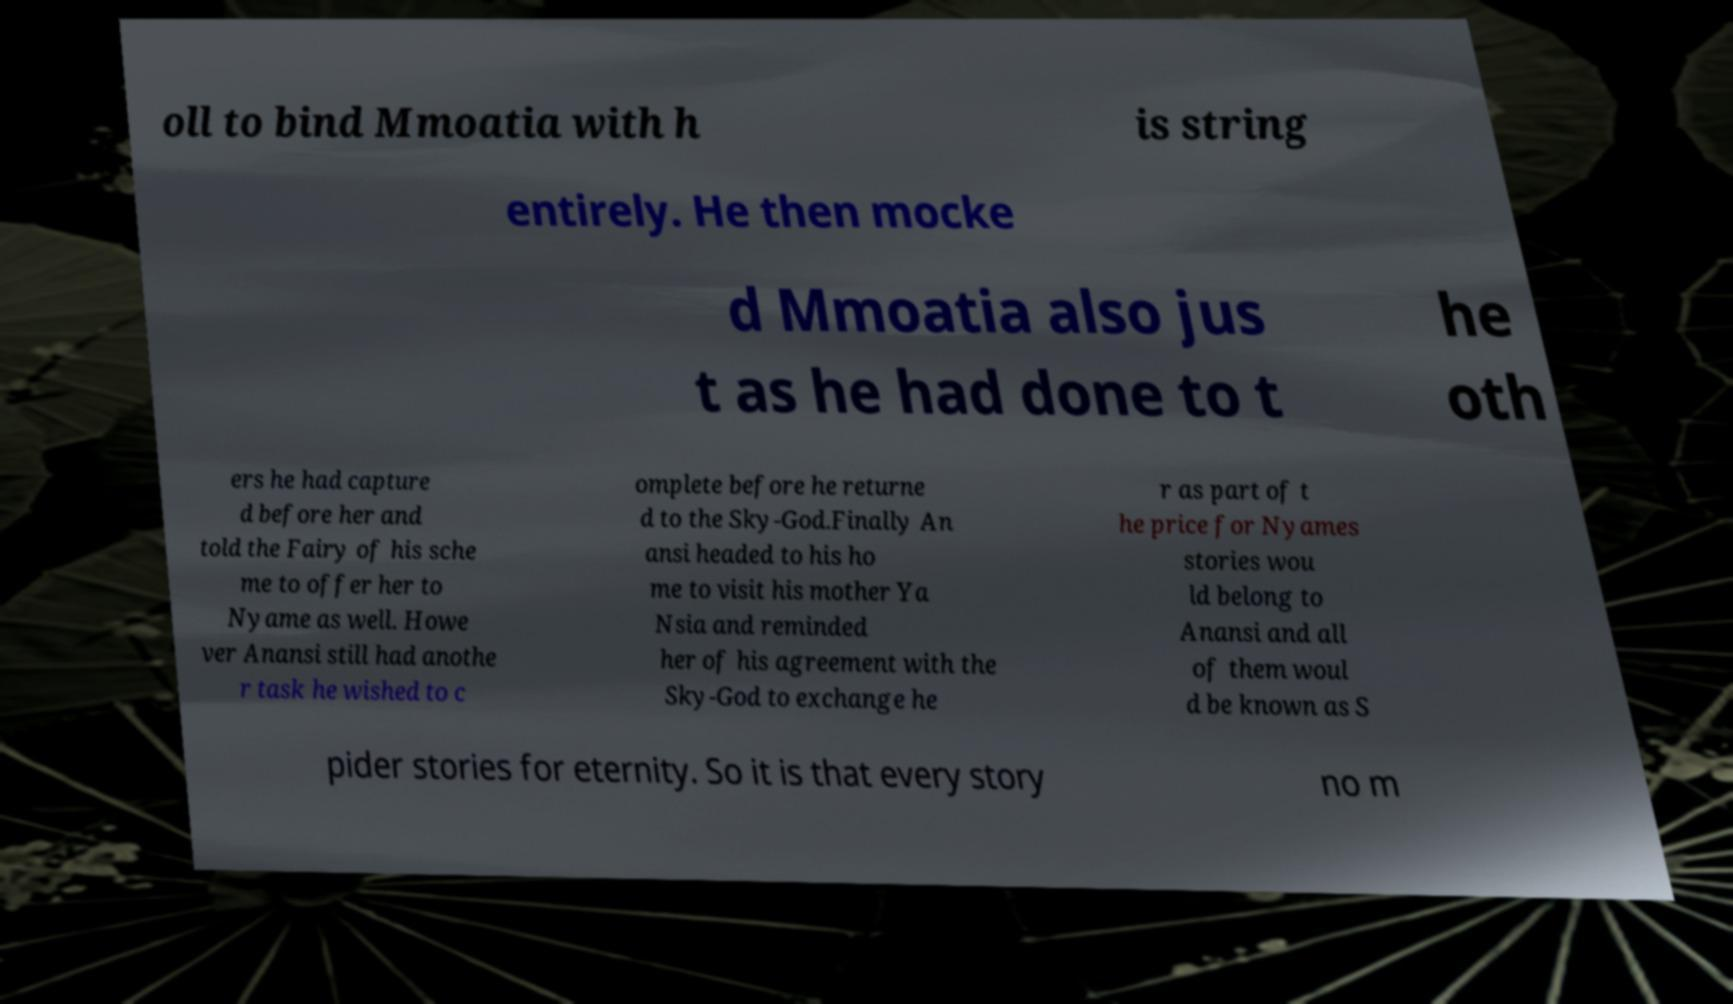Could you assist in decoding the text presented in this image and type it out clearly? oll to bind Mmoatia with h is string entirely. He then mocke d Mmoatia also jus t as he had done to t he oth ers he had capture d before her and told the Fairy of his sche me to offer her to Nyame as well. Howe ver Anansi still had anothe r task he wished to c omplete before he returne d to the Sky-God.Finally An ansi headed to his ho me to visit his mother Ya Nsia and reminded her of his agreement with the Sky-God to exchange he r as part of t he price for Nyames stories wou ld belong to Anansi and all of them woul d be known as S pider stories for eternity. So it is that every story no m 